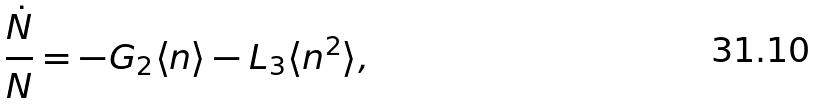Convert formula to latex. <formula><loc_0><loc_0><loc_500><loc_500>\frac { \dot { N } } { N } = - G _ { 2 } \langle n \rangle - L _ { 3 } \langle n ^ { 2 } \rangle ,</formula> 